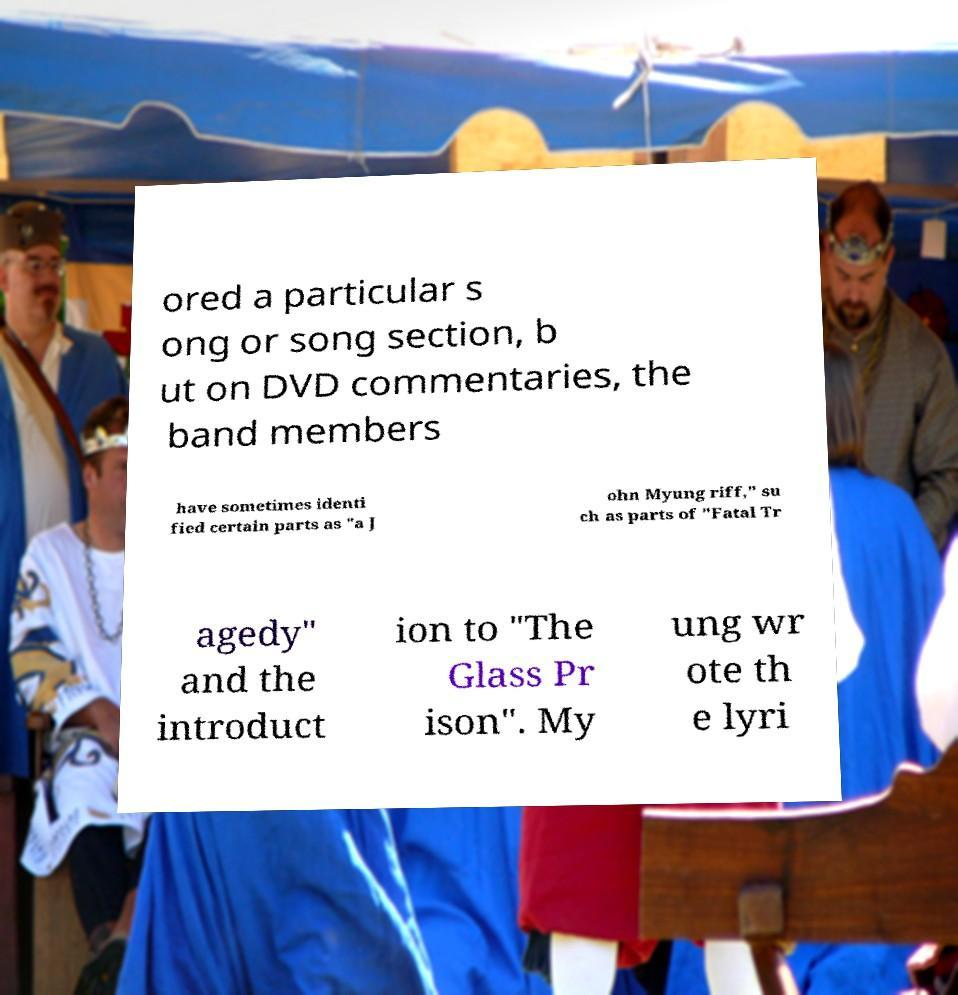Please identify and transcribe the text found in this image. ored a particular s ong or song section, b ut on DVD commentaries, the band members have sometimes identi fied certain parts as "a J ohn Myung riff," su ch as parts of "Fatal Tr agedy" and the introduct ion to "The Glass Pr ison". My ung wr ote th e lyri 